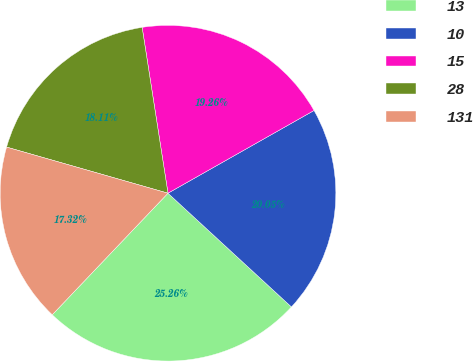Convert chart to OTSL. <chart><loc_0><loc_0><loc_500><loc_500><pie_chart><fcel>13<fcel>10<fcel>15<fcel>28<fcel>131<nl><fcel>25.26%<fcel>20.05%<fcel>19.26%<fcel>18.11%<fcel>17.32%<nl></chart> 